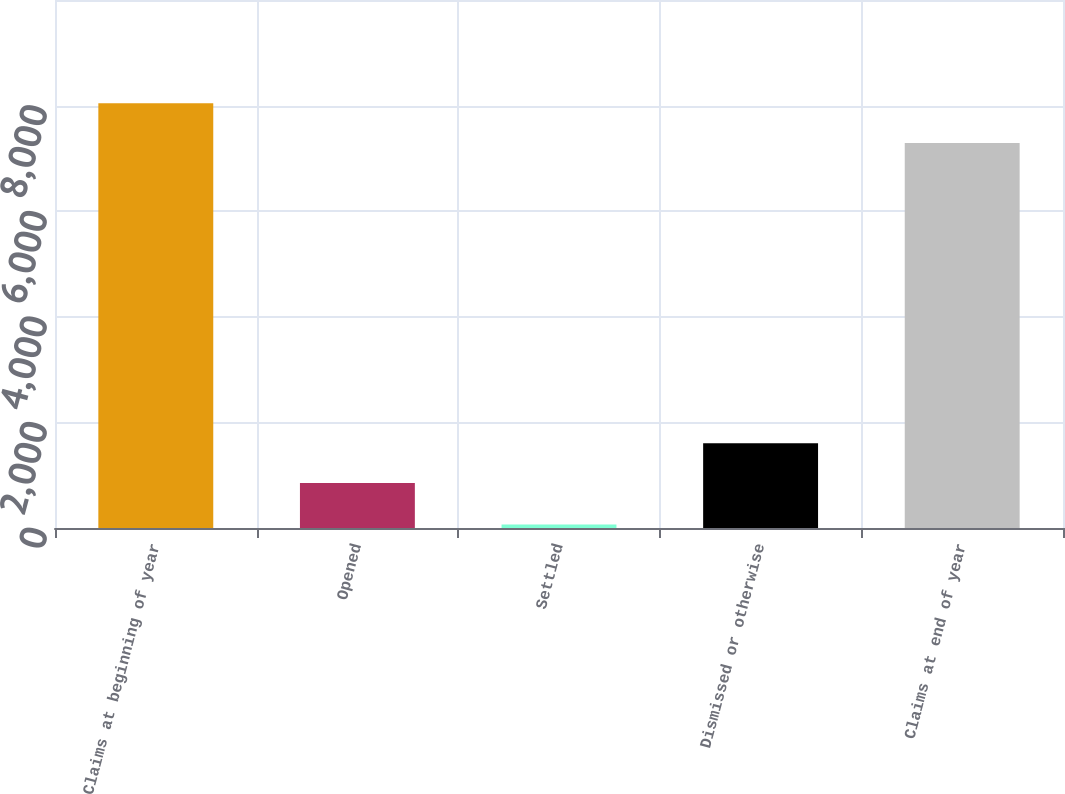<chart> <loc_0><loc_0><loc_500><loc_500><bar_chart><fcel>Claims at beginning of year<fcel>Opened<fcel>Settled<fcel>Dismissed or otherwise<fcel>Claims at end of year<nl><fcel>8043.8<fcel>854<fcel>67<fcel>1604.8<fcel>7293<nl></chart> 